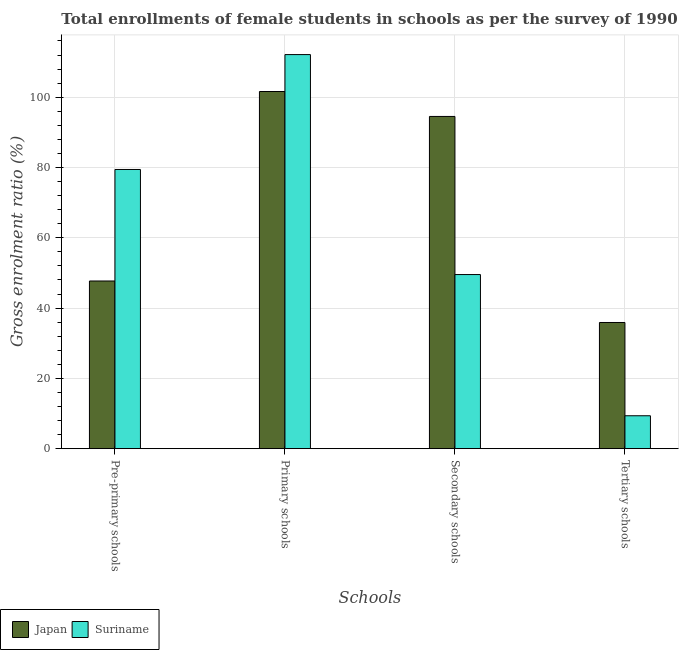How many different coloured bars are there?
Provide a short and direct response. 2. Are the number of bars on each tick of the X-axis equal?
Your answer should be compact. Yes. How many bars are there on the 2nd tick from the left?
Offer a terse response. 2. What is the label of the 2nd group of bars from the left?
Provide a succinct answer. Primary schools. What is the gross enrolment ratio(female) in tertiary schools in Suriname?
Offer a very short reply. 9.37. Across all countries, what is the maximum gross enrolment ratio(female) in primary schools?
Your response must be concise. 112.12. Across all countries, what is the minimum gross enrolment ratio(female) in pre-primary schools?
Ensure brevity in your answer.  47.71. In which country was the gross enrolment ratio(female) in pre-primary schools maximum?
Your response must be concise. Suriname. In which country was the gross enrolment ratio(female) in pre-primary schools minimum?
Make the answer very short. Japan. What is the total gross enrolment ratio(female) in tertiary schools in the graph?
Your answer should be compact. 45.27. What is the difference between the gross enrolment ratio(female) in pre-primary schools in Japan and that in Suriname?
Provide a short and direct response. -31.73. What is the difference between the gross enrolment ratio(female) in primary schools in Japan and the gross enrolment ratio(female) in secondary schools in Suriname?
Your response must be concise. 52.08. What is the average gross enrolment ratio(female) in pre-primary schools per country?
Provide a succinct answer. 63.57. What is the difference between the gross enrolment ratio(female) in pre-primary schools and gross enrolment ratio(female) in tertiary schools in Japan?
Ensure brevity in your answer.  11.81. What is the ratio of the gross enrolment ratio(female) in primary schools in Suriname to that in Japan?
Your answer should be compact. 1.1. Is the gross enrolment ratio(female) in secondary schools in Suriname less than that in Japan?
Your answer should be very brief. Yes. What is the difference between the highest and the second highest gross enrolment ratio(female) in primary schools?
Ensure brevity in your answer.  10.51. What is the difference between the highest and the lowest gross enrolment ratio(female) in tertiary schools?
Your answer should be compact. 26.54. In how many countries, is the gross enrolment ratio(female) in pre-primary schools greater than the average gross enrolment ratio(female) in pre-primary schools taken over all countries?
Offer a terse response. 1. What does the 1st bar from the left in Pre-primary schools represents?
Provide a succinct answer. Japan. What does the 1st bar from the right in Pre-primary schools represents?
Give a very brief answer. Suriname. Is it the case that in every country, the sum of the gross enrolment ratio(female) in pre-primary schools and gross enrolment ratio(female) in primary schools is greater than the gross enrolment ratio(female) in secondary schools?
Provide a succinct answer. Yes. How many bars are there?
Your response must be concise. 8. Are all the bars in the graph horizontal?
Provide a short and direct response. No. Are the values on the major ticks of Y-axis written in scientific E-notation?
Keep it short and to the point. No. Does the graph contain any zero values?
Keep it short and to the point. No. How many legend labels are there?
Offer a very short reply. 2. What is the title of the graph?
Your answer should be compact. Total enrollments of female students in schools as per the survey of 1990 conducted in different countries. What is the label or title of the X-axis?
Ensure brevity in your answer.  Schools. What is the label or title of the Y-axis?
Provide a short and direct response. Gross enrolment ratio (%). What is the Gross enrolment ratio (%) of Japan in Pre-primary schools?
Keep it short and to the point. 47.71. What is the Gross enrolment ratio (%) in Suriname in Pre-primary schools?
Your answer should be compact. 79.44. What is the Gross enrolment ratio (%) in Japan in Primary schools?
Your response must be concise. 101.62. What is the Gross enrolment ratio (%) of Suriname in Primary schools?
Ensure brevity in your answer.  112.12. What is the Gross enrolment ratio (%) in Japan in Secondary schools?
Make the answer very short. 94.52. What is the Gross enrolment ratio (%) in Suriname in Secondary schools?
Provide a succinct answer. 49.54. What is the Gross enrolment ratio (%) in Japan in Tertiary schools?
Your response must be concise. 35.9. What is the Gross enrolment ratio (%) of Suriname in Tertiary schools?
Ensure brevity in your answer.  9.37. Across all Schools, what is the maximum Gross enrolment ratio (%) of Japan?
Keep it short and to the point. 101.62. Across all Schools, what is the maximum Gross enrolment ratio (%) in Suriname?
Give a very brief answer. 112.12. Across all Schools, what is the minimum Gross enrolment ratio (%) in Japan?
Ensure brevity in your answer.  35.9. Across all Schools, what is the minimum Gross enrolment ratio (%) of Suriname?
Offer a terse response. 9.37. What is the total Gross enrolment ratio (%) in Japan in the graph?
Provide a succinct answer. 279.75. What is the total Gross enrolment ratio (%) in Suriname in the graph?
Make the answer very short. 250.47. What is the difference between the Gross enrolment ratio (%) in Japan in Pre-primary schools and that in Primary schools?
Give a very brief answer. -53.91. What is the difference between the Gross enrolment ratio (%) in Suriname in Pre-primary schools and that in Primary schools?
Keep it short and to the point. -32.69. What is the difference between the Gross enrolment ratio (%) in Japan in Pre-primary schools and that in Secondary schools?
Provide a succinct answer. -46.81. What is the difference between the Gross enrolment ratio (%) of Suriname in Pre-primary schools and that in Secondary schools?
Make the answer very short. 29.9. What is the difference between the Gross enrolment ratio (%) of Japan in Pre-primary schools and that in Tertiary schools?
Ensure brevity in your answer.  11.81. What is the difference between the Gross enrolment ratio (%) in Suriname in Pre-primary schools and that in Tertiary schools?
Ensure brevity in your answer.  70.07. What is the difference between the Gross enrolment ratio (%) in Japan in Primary schools and that in Secondary schools?
Provide a succinct answer. 7.1. What is the difference between the Gross enrolment ratio (%) in Suriname in Primary schools and that in Secondary schools?
Make the answer very short. 62.58. What is the difference between the Gross enrolment ratio (%) of Japan in Primary schools and that in Tertiary schools?
Provide a short and direct response. 65.72. What is the difference between the Gross enrolment ratio (%) of Suriname in Primary schools and that in Tertiary schools?
Your response must be concise. 102.76. What is the difference between the Gross enrolment ratio (%) in Japan in Secondary schools and that in Tertiary schools?
Your answer should be compact. 58.62. What is the difference between the Gross enrolment ratio (%) of Suriname in Secondary schools and that in Tertiary schools?
Offer a very short reply. 40.18. What is the difference between the Gross enrolment ratio (%) of Japan in Pre-primary schools and the Gross enrolment ratio (%) of Suriname in Primary schools?
Your answer should be compact. -64.42. What is the difference between the Gross enrolment ratio (%) of Japan in Pre-primary schools and the Gross enrolment ratio (%) of Suriname in Secondary schools?
Offer a very short reply. -1.83. What is the difference between the Gross enrolment ratio (%) in Japan in Pre-primary schools and the Gross enrolment ratio (%) in Suriname in Tertiary schools?
Offer a terse response. 38.34. What is the difference between the Gross enrolment ratio (%) in Japan in Primary schools and the Gross enrolment ratio (%) in Suriname in Secondary schools?
Offer a terse response. 52.08. What is the difference between the Gross enrolment ratio (%) in Japan in Primary schools and the Gross enrolment ratio (%) in Suriname in Tertiary schools?
Your answer should be very brief. 92.25. What is the difference between the Gross enrolment ratio (%) of Japan in Secondary schools and the Gross enrolment ratio (%) of Suriname in Tertiary schools?
Ensure brevity in your answer.  85.16. What is the average Gross enrolment ratio (%) of Japan per Schools?
Your answer should be compact. 69.94. What is the average Gross enrolment ratio (%) in Suriname per Schools?
Your answer should be compact. 62.62. What is the difference between the Gross enrolment ratio (%) in Japan and Gross enrolment ratio (%) in Suriname in Pre-primary schools?
Provide a succinct answer. -31.73. What is the difference between the Gross enrolment ratio (%) in Japan and Gross enrolment ratio (%) in Suriname in Primary schools?
Your answer should be very brief. -10.51. What is the difference between the Gross enrolment ratio (%) of Japan and Gross enrolment ratio (%) of Suriname in Secondary schools?
Your answer should be very brief. 44.98. What is the difference between the Gross enrolment ratio (%) of Japan and Gross enrolment ratio (%) of Suriname in Tertiary schools?
Give a very brief answer. 26.54. What is the ratio of the Gross enrolment ratio (%) in Japan in Pre-primary schools to that in Primary schools?
Make the answer very short. 0.47. What is the ratio of the Gross enrolment ratio (%) in Suriname in Pre-primary schools to that in Primary schools?
Your answer should be compact. 0.71. What is the ratio of the Gross enrolment ratio (%) in Japan in Pre-primary schools to that in Secondary schools?
Offer a very short reply. 0.5. What is the ratio of the Gross enrolment ratio (%) of Suriname in Pre-primary schools to that in Secondary schools?
Give a very brief answer. 1.6. What is the ratio of the Gross enrolment ratio (%) of Japan in Pre-primary schools to that in Tertiary schools?
Ensure brevity in your answer.  1.33. What is the ratio of the Gross enrolment ratio (%) in Suriname in Pre-primary schools to that in Tertiary schools?
Ensure brevity in your answer.  8.48. What is the ratio of the Gross enrolment ratio (%) in Japan in Primary schools to that in Secondary schools?
Provide a short and direct response. 1.08. What is the ratio of the Gross enrolment ratio (%) in Suriname in Primary schools to that in Secondary schools?
Keep it short and to the point. 2.26. What is the ratio of the Gross enrolment ratio (%) of Japan in Primary schools to that in Tertiary schools?
Ensure brevity in your answer.  2.83. What is the ratio of the Gross enrolment ratio (%) of Suriname in Primary schools to that in Tertiary schools?
Keep it short and to the point. 11.97. What is the ratio of the Gross enrolment ratio (%) of Japan in Secondary schools to that in Tertiary schools?
Keep it short and to the point. 2.63. What is the ratio of the Gross enrolment ratio (%) in Suriname in Secondary schools to that in Tertiary schools?
Offer a terse response. 5.29. What is the difference between the highest and the second highest Gross enrolment ratio (%) in Japan?
Your answer should be very brief. 7.1. What is the difference between the highest and the second highest Gross enrolment ratio (%) in Suriname?
Give a very brief answer. 32.69. What is the difference between the highest and the lowest Gross enrolment ratio (%) in Japan?
Your answer should be very brief. 65.72. What is the difference between the highest and the lowest Gross enrolment ratio (%) in Suriname?
Provide a short and direct response. 102.76. 